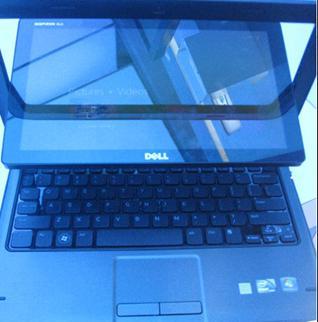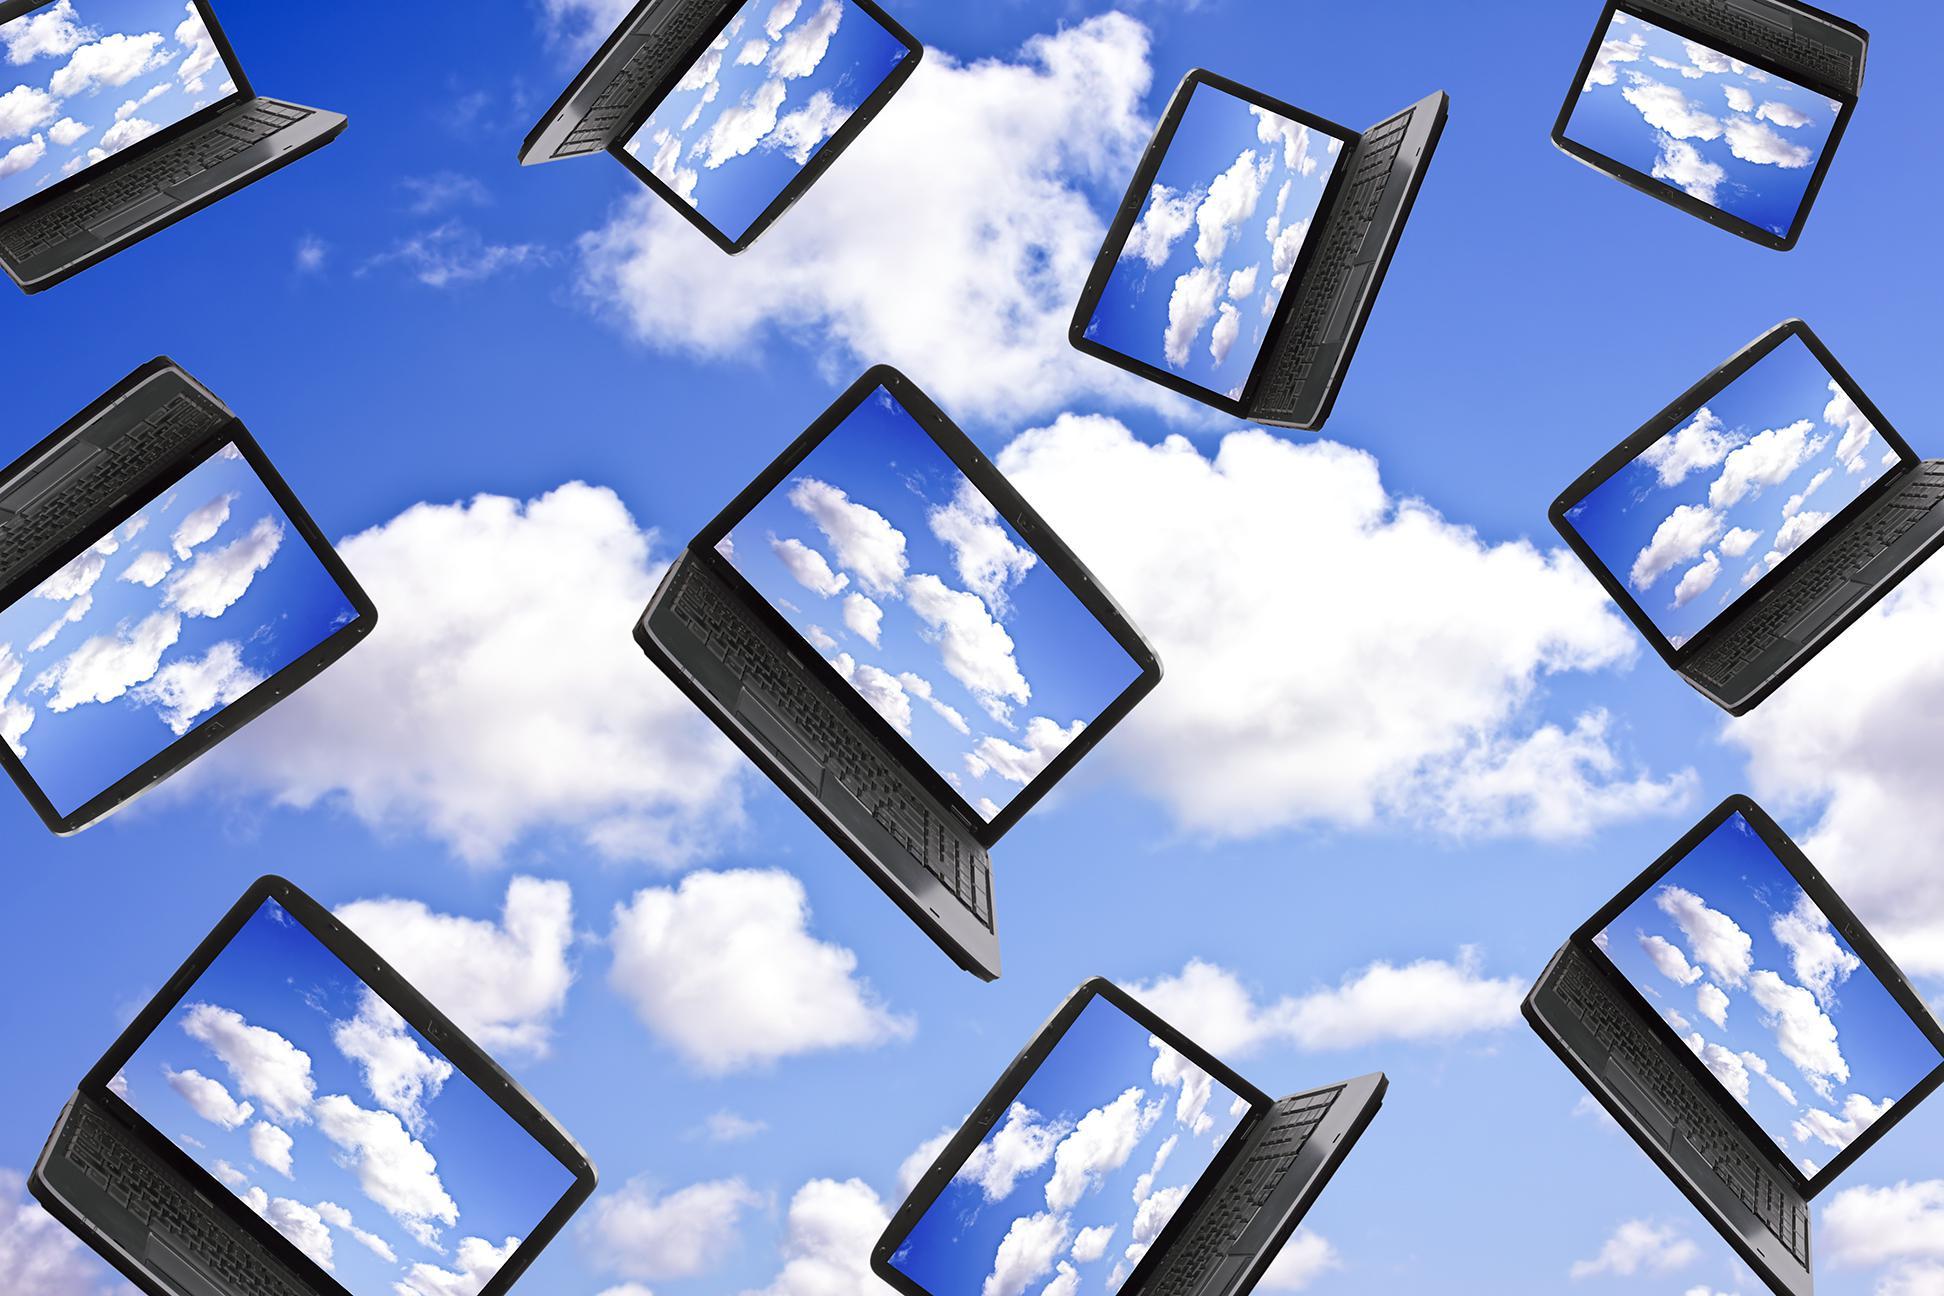The first image is the image on the left, the second image is the image on the right. Evaluate the accuracy of this statement regarding the images: "There are more than two laptops.". Is it true? Answer yes or no. Yes. 